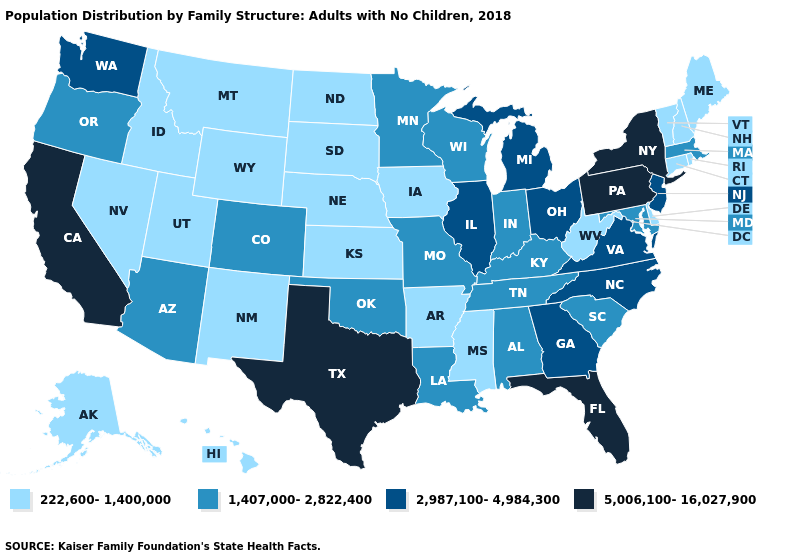Does Indiana have the highest value in the MidWest?
Short answer required. No. How many symbols are there in the legend?
Quick response, please. 4. Among the states that border Idaho , which have the lowest value?
Answer briefly. Montana, Nevada, Utah, Wyoming. Name the states that have a value in the range 2,987,100-4,984,300?
Concise answer only. Georgia, Illinois, Michigan, New Jersey, North Carolina, Ohio, Virginia, Washington. Which states have the lowest value in the USA?
Be succinct. Alaska, Arkansas, Connecticut, Delaware, Hawaii, Idaho, Iowa, Kansas, Maine, Mississippi, Montana, Nebraska, Nevada, New Hampshire, New Mexico, North Dakota, Rhode Island, South Dakota, Utah, Vermont, West Virginia, Wyoming. Among the states that border Delaware , does New Jersey have the lowest value?
Be succinct. No. Name the states that have a value in the range 2,987,100-4,984,300?
Be succinct. Georgia, Illinois, Michigan, New Jersey, North Carolina, Ohio, Virginia, Washington. What is the value of Nevada?
Answer briefly. 222,600-1,400,000. Name the states that have a value in the range 2,987,100-4,984,300?
Write a very short answer. Georgia, Illinois, Michigan, New Jersey, North Carolina, Ohio, Virginia, Washington. Does Texas have the highest value in the USA?
Short answer required. Yes. Does Wyoming have a higher value than Maryland?
Be succinct. No. Which states have the lowest value in the Northeast?
Answer briefly. Connecticut, Maine, New Hampshire, Rhode Island, Vermont. Does Maryland have the highest value in the South?
Keep it brief. No. What is the value of Alabama?
Short answer required. 1,407,000-2,822,400. Name the states that have a value in the range 5,006,100-16,027,900?
Give a very brief answer. California, Florida, New York, Pennsylvania, Texas. 